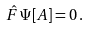<formula> <loc_0><loc_0><loc_500><loc_500>\hat { F } \, \Psi [ A ] = 0 \, .</formula> 